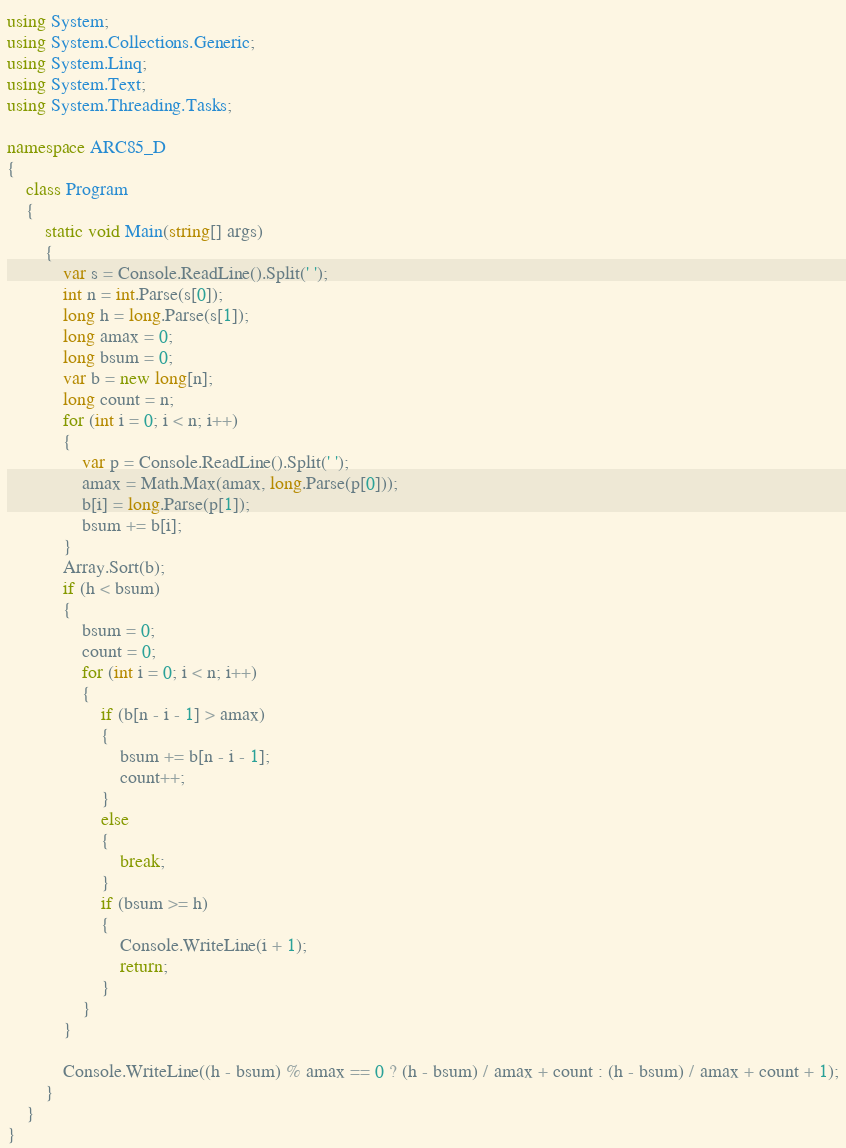Convert code to text. <code><loc_0><loc_0><loc_500><loc_500><_C#_>using System;
using System.Collections.Generic;
using System.Linq;
using System.Text;
using System.Threading.Tasks;

namespace ARC85_D
{
    class Program
    {
        static void Main(string[] args)
        {
            var s = Console.ReadLine().Split(' ');
            int n = int.Parse(s[0]);
            long h = long.Parse(s[1]);
            long amax = 0;
            long bsum = 0;
            var b = new long[n];
            long count = n;
            for (int i = 0; i < n; i++)
            {
                var p = Console.ReadLine().Split(' ');
                amax = Math.Max(amax, long.Parse(p[0]));
                b[i] = long.Parse(p[1]);
                bsum += b[i];
            }
            Array.Sort(b);
            if (h < bsum)
            {
                bsum = 0;
                count = 0;
                for (int i = 0; i < n; i++)
                {
                    if (b[n - i - 1] > amax)
                    {
                        bsum += b[n - i - 1];
                        count++;
                    }
                    else
                    {
                        break;
                    }
                    if (bsum >= h)
                    {
                        Console.WriteLine(i + 1);
                        return;
                    }
                }
            }

            Console.WriteLine((h - bsum) % amax == 0 ? (h - bsum) / amax + count : (h - bsum) / amax + count + 1);
        }
    }
}
</code> 